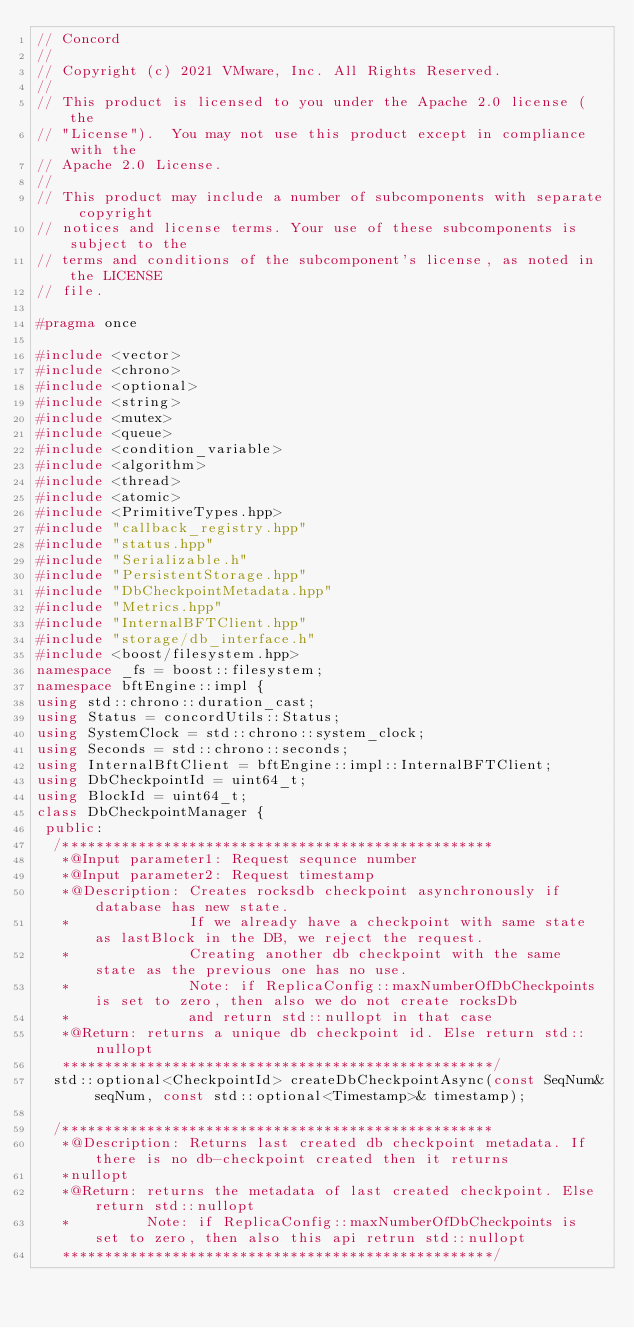Convert code to text. <code><loc_0><loc_0><loc_500><loc_500><_C++_>// Concord
//
// Copyright (c) 2021 VMware, Inc. All Rights Reserved.
//
// This product is licensed to you under the Apache 2.0 license (the
// "License").  You may not use this product except in compliance with the
// Apache 2.0 License.
//
// This product may include a number of subcomponents with separate copyright
// notices and license terms. Your use of these subcomponents is subject to the
// terms and conditions of the subcomponent's license, as noted in the LICENSE
// file.

#pragma once

#include <vector>
#include <chrono>
#include <optional>
#include <string>
#include <mutex>
#include <queue>
#include <condition_variable>
#include <algorithm>
#include <thread>
#include <atomic>
#include <PrimitiveTypes.hpp>
#include "callback_registry.hpp"
#include "status.hpp"
#include "Serializable.h"
#include "PersistentStorage.hpp"
#include "DbCheckpointMetadata.hpp"
#include "Metrics.hpp"
#include "InternalBFTClient.hpp"
#include "storage/db_interface.h"
#include <boost/filesystem.hpp>
namespace _fs = boost::filesystem;
namespace bftEngine::impl {
using std::chrono::duration_cast;
using Status = concordUtils::Status;
using SystemClock = std::chrono::system_clock;
using Seconds = std::chrono::seconds;
using InternalBftClient = bftEngine::impl::InternalBFTClient;
using DbCheckpointId = uint64_t;
using BlockId = uint64_t;
class DbCheckpointManager {
 public:
  /***************************************************
   *@Input parameter1: Request sequnce number
   *@Input parameter2: Request timestamp
   *@Description: Creates rocksdb checkpoint asynchronously if database has new state.
   *              If we already have a checkpoint with same state as lastBlock in the DB, we reject the request.
   *              Creating another db checkpoint with the same state as the previous one has no use.
   *              Note: if ReplicaConfig::maxNumberOfDbCheckpoints is set to zero, then also we do not create rocksDb
   *              and return std::nullopt in that case
   *@Return: returns a unique db checkpoint id. Else return std::nullopt
   ***************************************************/
  std::optional<CheckpointId> createDbCheckpointAsync(const SeqNum& seqNum, const std::optional<Timestamp>& timestamp);

  /***************************************************
   *@Description: Returns last created db checkpoint metadata. If there is no db-checkpoint created then it returns
   *nullopt
   *@Return: returns the metadata of last created checkpoint. Else return std::nullopt
   *         Note: if ReplicaConfig::maxNumberOfDbCheckpoints is set to zero, then also this api retrun std::nullopt
   ***************************************************/</code> 